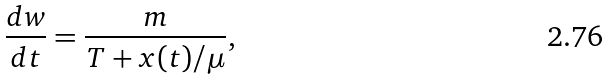Convert formula to latex. <formula><loc_0><loc_0><loc_500><loc_500>\frac { d w } { d t } = \frac { m } { T + x ( t ) / \mu } ,</formula> 